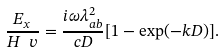<formula> <loc_0><loc_0><loc_500><loc_500>\frac { E _ { x } } { H ^ { \ } v } = \frac { { i } \omega \lambda _ { a b } ^ { 2 } } { c D } [ 1 - \exp ( - k D ) ] .</formula> 